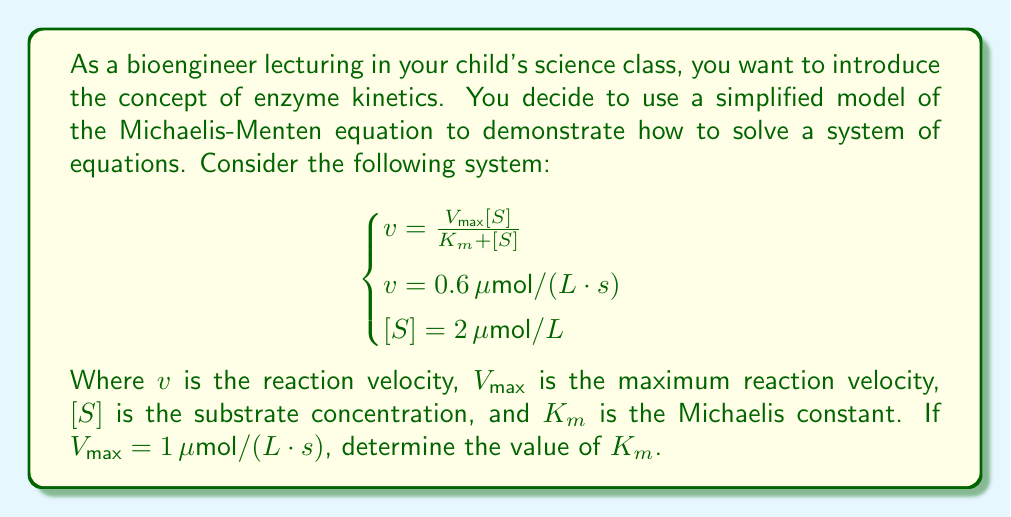Can you answer this question? Let's solve this system of equations step by step:

1) We're given that $V_{max} = 1 \, \mu mol/(L \cdot s)$, $v = 0.6 \, \mu mol/(L \cdot s)$, and $[S] = 2 \, \mu mol/L$. We need to find $K_m$.

2) Let's substitute these values into the Michaelis-Menten equation:

   $$0.6 = \frac{1 \cdot 2}{K_m + 2}$$

3) Now, let's solve this equation for $K_m$:

   $$0.6(K_m + 2) = 2$$
   
   $$0.6K_m + 1.2 = 2$$
   
   $$0.6K_m = 0.8$$

4) Dividing both sides by 0.6:

   $$K_m = \frac{0.8}{0.6} = \frac{4}{3} \approx 1.33$$

Therefore, the Michaelis constant $K_m$ is $\frac{4}{3} \, \mu mol/L$ or approximately $1.33 \, \mu mol/L$.
Answer: $K_m = \frac{4}{3} \, \mu mol/L \approx 1.33 \, \mu mol/L$ 